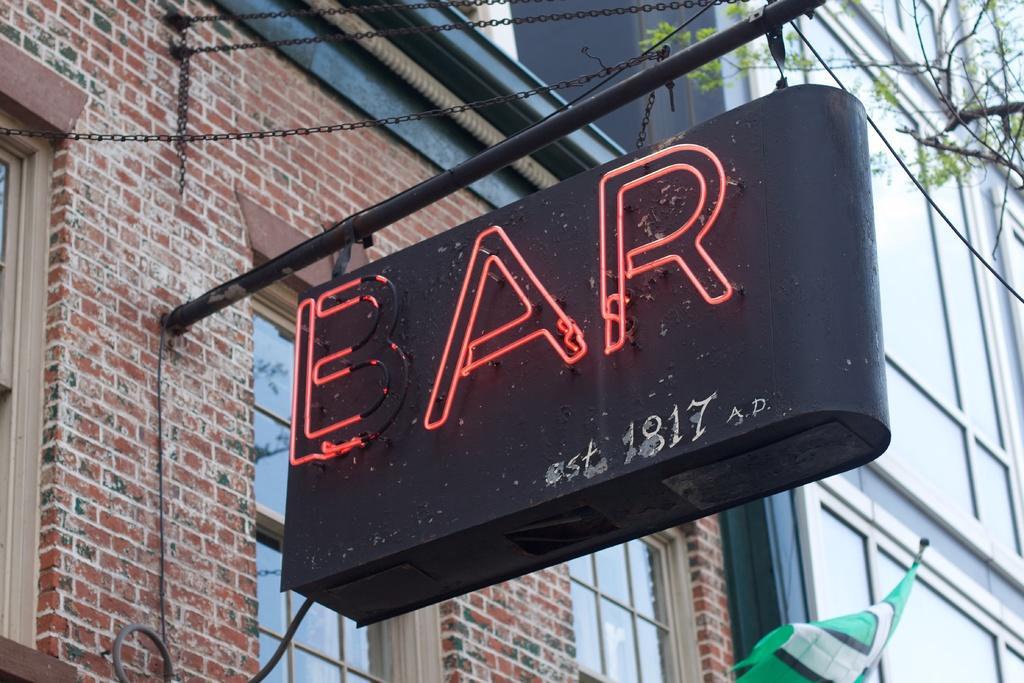Could you give a brief overview of what you see in this image? In the image we can see a building and the windows of the building. There is a board, on which it is written bar. There is a tree and a cloth, green in color. 